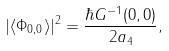Convert formula to latex. <formula><loc_0><loc_0><loc_500><loc_500>| \langle \Phi _ { { 0 } , 0 } \rangle | ^ { 2 } = \frac { \hbar { G } ^ { - 1 } ( { 0 } , 0 ) } { 2 a _ { 4 } } ,</formula> 